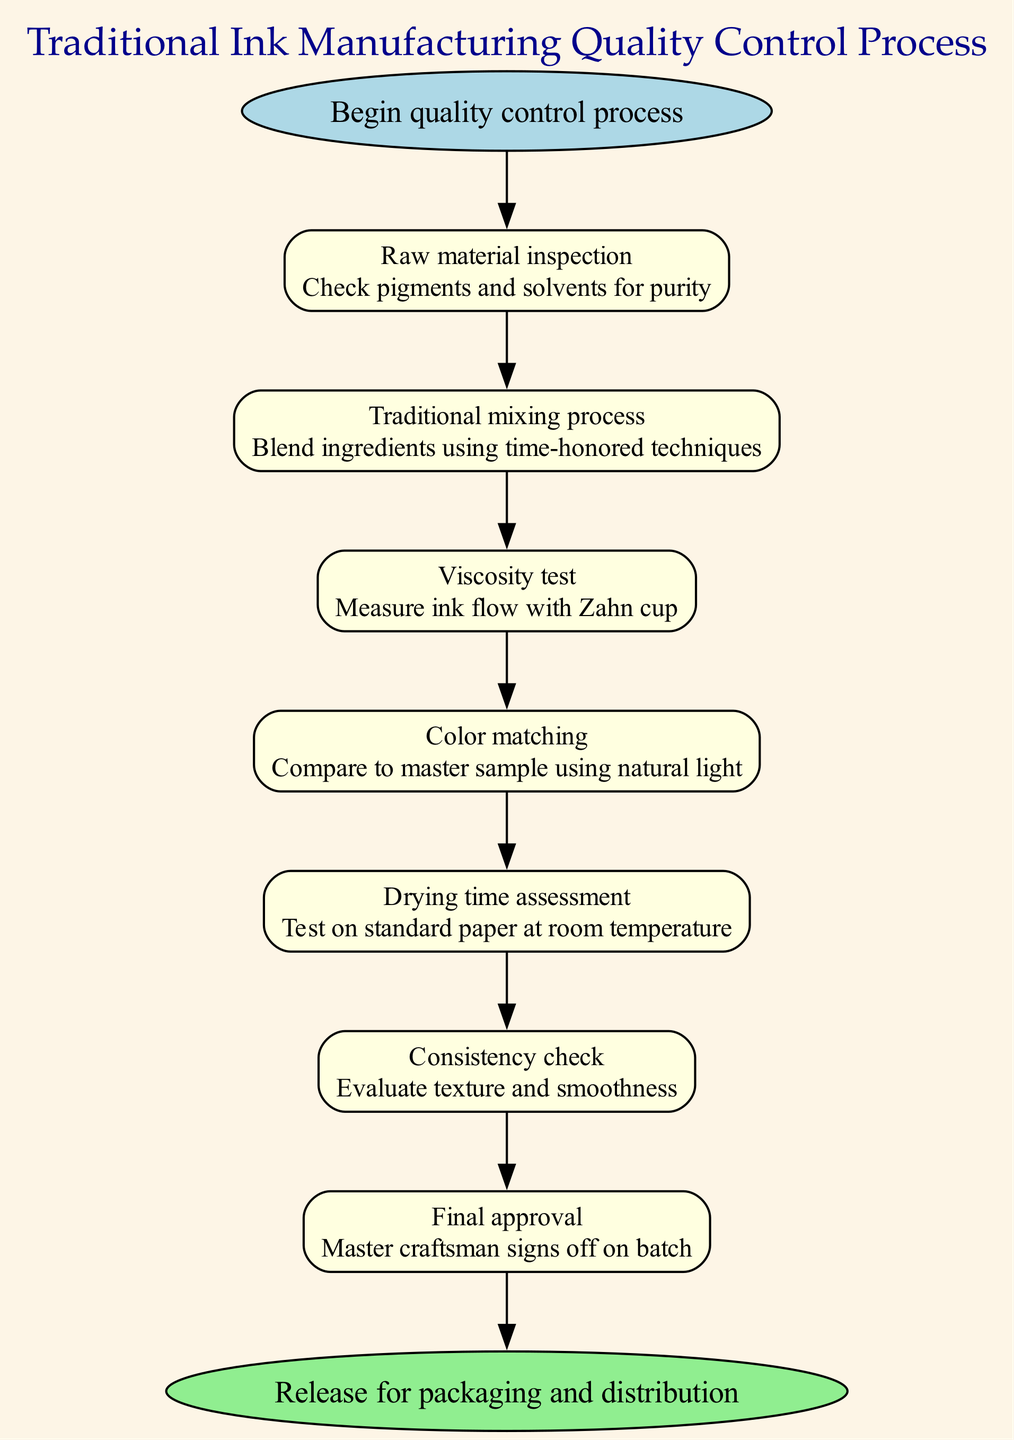What is the first step in the quality control process? The first node in the diagram, representing the initiation of the process, is labeled "Begin quality control process." Therefore, this is the first step.
Answer: Begin quality control process How many steps are there in the quality control process? By counting the individual process steps listed within the diagram, there are seven explicit steps from raw material inspection to final approval, indicating the total number of steps.
Answer: Seven What does the "Color matching" step involve? The node labeled "Color matching" in the diagram states it involves comparing the ink to a master sample using natural light. This succinctly describes what happens during this step.
Answer: Compare to master sample using natural light What comes immediately after the "Viscosity test"? Tracing the flow of the diagram, the node connected after "Viscosity test" is "Color matching," indicating this is the next step to follow viscosity testing.
Answer: Color matching Which step requires the signature of a master craftsman? The last step in the process, labeled "Final approval," clearly indicates that it is where the master craftsman signs off on the batch, confirming the involvement of a master craftsman.
Answer: Final approval What is evaluated during the "Consistency check"? According to the description in the node for "Consistency check," the evaluation pertains to the texture and smoothness of the ink, detailing what specifically is assessed at this stage.
Answer: Evaluate texture and smoothness How does "Drying time assessment" contribute to the process? The "Drying time assessment" step is designed to test the ink on standard paper at room temperature, which helps ascertain whether the ink dries appropriately under specific conditions—thus confirming its usability.
Answer: Test on standard paper at room temperature What type of inspection is performed on raw materials? The raw material inspection step requires checking pigments and solvents for purity, as described in that node, which highlights the quality assurance performed on these inputs.
Answer: Check pigments and solvents for purity 